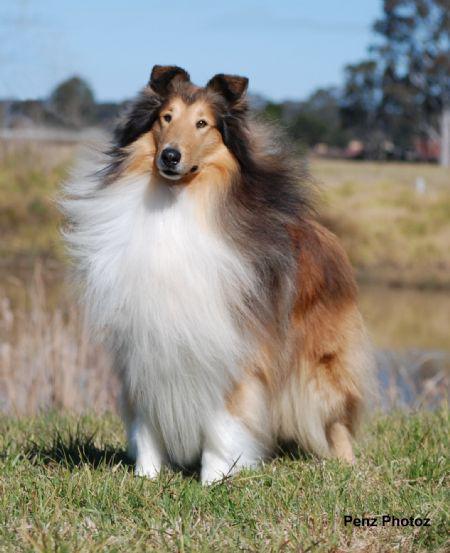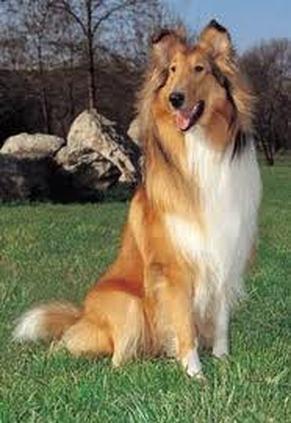The first image is the image on the left, the second image is the image on the right. Considering the images on both sides, is "The dog in the image on the right is not standing on grass." valid? Answer yes or no. No. 